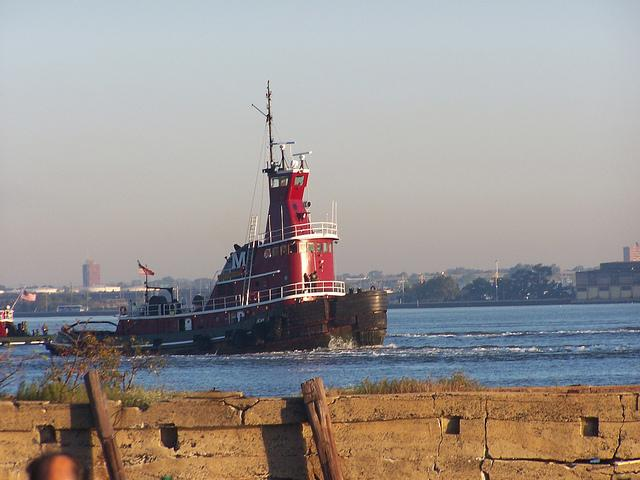The boat here moves under what sort of power? steam 